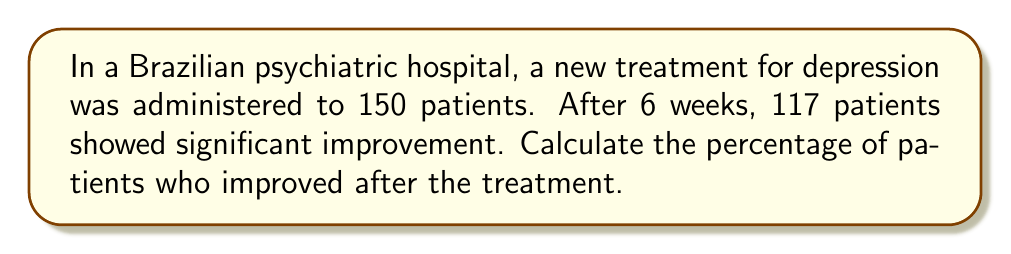Provide a solution to this math problem. To calculate the percentage of patients showing improvement, we need to follow these steps:

1. Identify the total number of patients: 150
2. Identify the number of patients who improved: 117
3. Use the formula for percentage:

   $$ \text{Percentage} = \frac{\text{Number of patients who improved}}{\text{Total number of patients}} \times 100\% $$

4. Plug in the values:

   $$ \text{Percentage} = \frac{117}{150} \times 100\% $$

5. Simplify the fraction:
   
   $$ \text{Percentage} = 0.78 \times 100\% $$

6. Calculate the final percentage:

   $$ \text{Percentage} = 78\% $$

Therefore, 78% of the patients showed improvement after the treatment.
Answer: 78% 